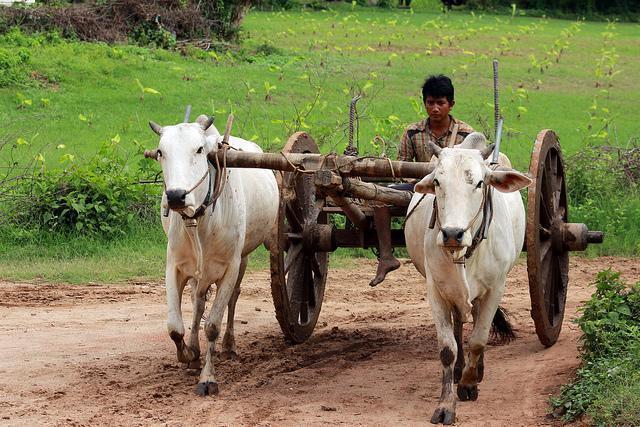What kind of animal is the cart pulled by?
Indicate the correct choice and explain in the format: 'Answer: answer
Rationale: rationale.'
Options: Goat, ox, cow, horse. Answer: ox.
Rationale: These ox are pulling the cart. What is behind the animals?
Answer the question by selecting the correct answer among the 4 following choices and explain your choice with a short sentence. The answer should be formatted with the following format: `Answer: choice
Rationale: rationale.`
Options: Wheels, cookies, ladder, baby. Answer: wheels.
Rationale: The animals are pulling the wheels. 